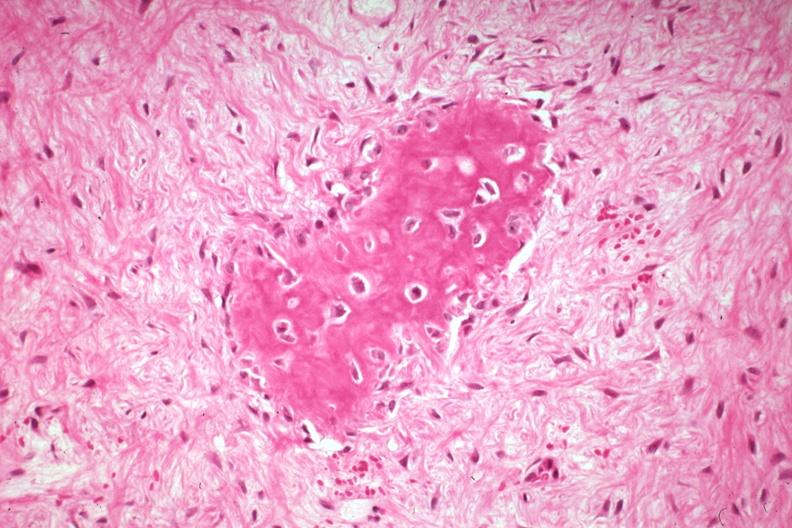does this image show high excessive fibrous callus in a non-union with area of osteoid deposition excellent example?
Answer the question using a single word or phrase. Yes 